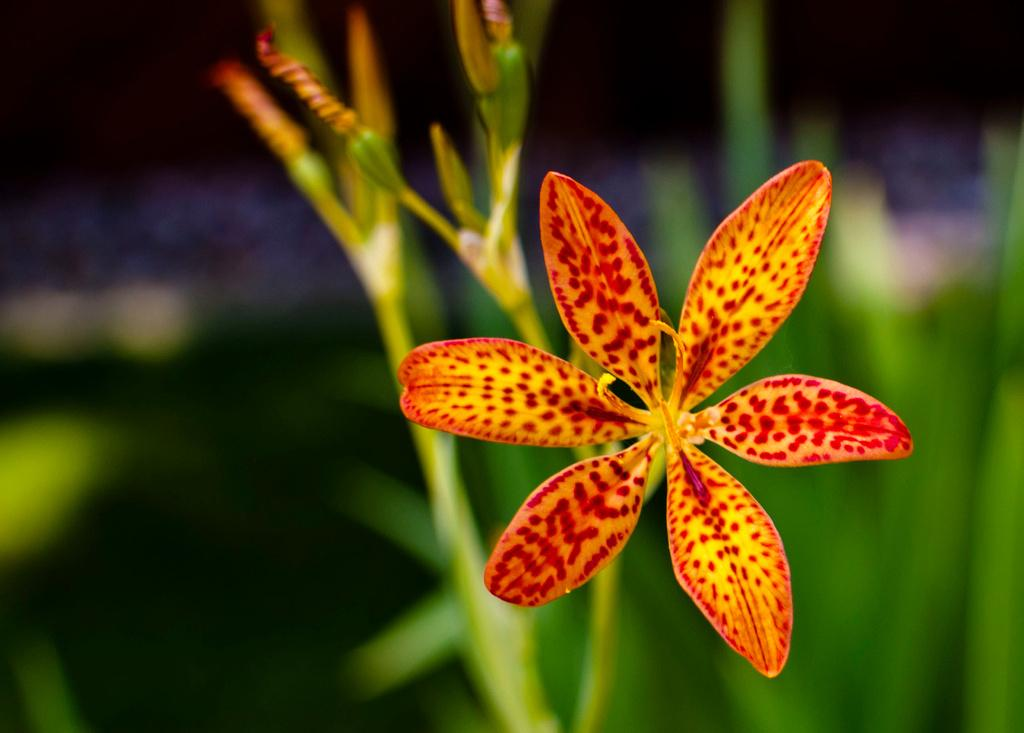What is the main subject of the image? The main subject of the image is a plant. Can you describe any specific features of the plant? There is one flower on the right side of the image. What type of coach can be seen in the background of the image? There is no coach present in the image; it is a zoomed-in view of a plant. What scent is emitted by the flower in the image? The image is a still photograph, so it does not convey any scents or smells. 